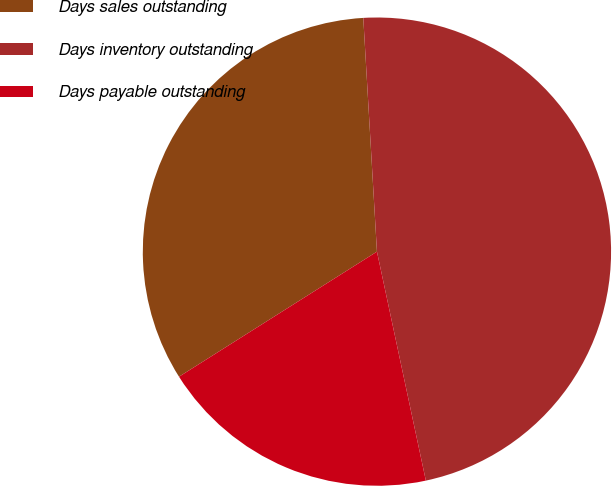<chart> <loc_0><loc_0><loc_500><loc_500><pie_chart><fcel>Days sales outstanding<fcel>Days inventory outstanding<fcel>Days payable outstanding<nl><fcel>33.04%<fcel>47.58%<fcel>19.38%<nl></chart> 